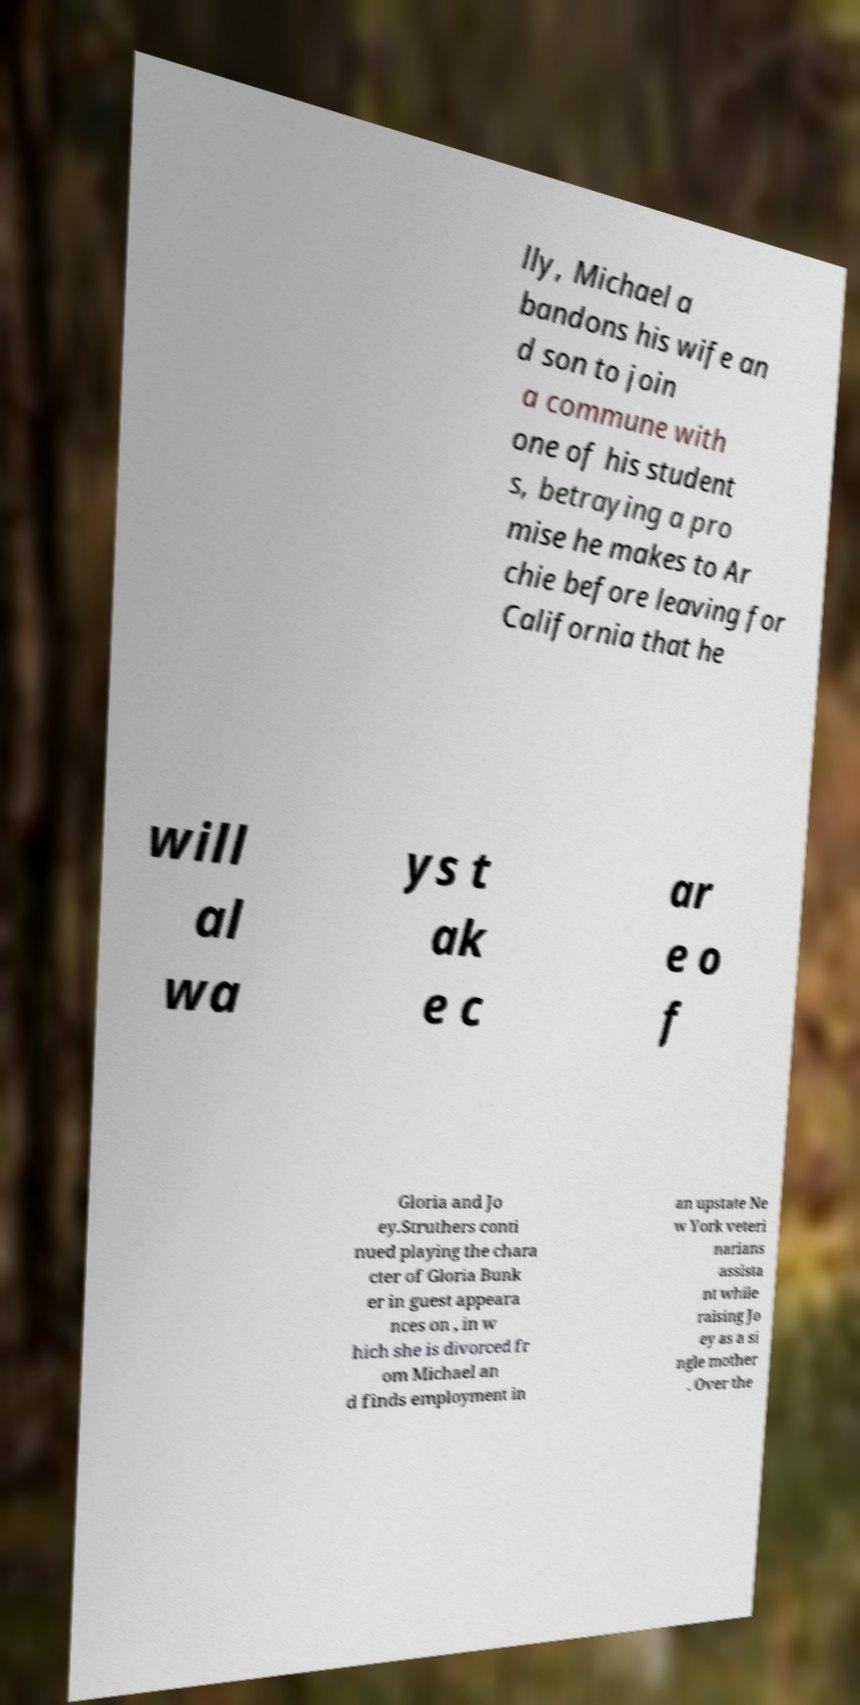Please identify and transcribe the text found in this image. lly, Michael a bandons his wife an d son to join a commune with one of his student s, betraying a pro mise he makes to Ar chie before leaving for California that he will al wa ys t ak e c ar e o f Gloria and Jo ey.Struthers conti nued playing the chara cter of Gloria Bunk er in guest appeara nces on , in w hich she is divorced fr om Michael an d finds employment in an upstate Ne w York veteri narians assista nt while raising Jo ey as a si ngle mother . Over the 